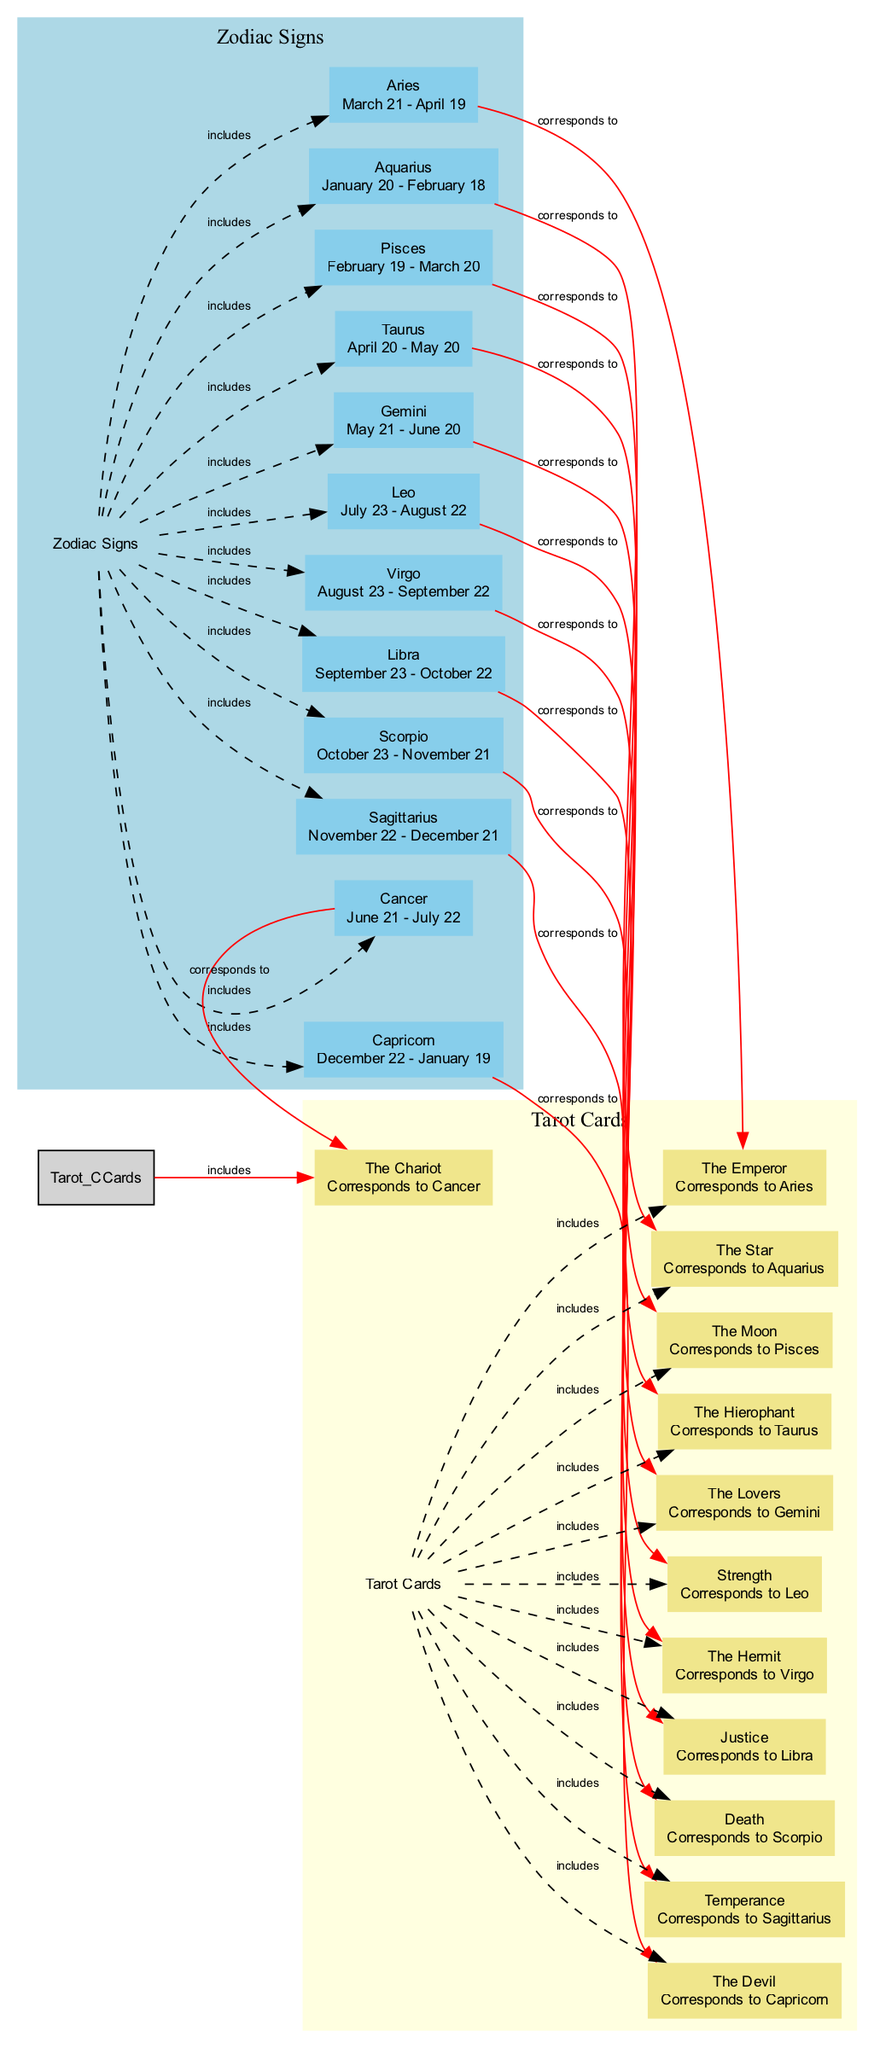What are the zodiac signs represented in the diagram? The diagram includes nodes for each of the twelve zodiac signs, which are Aries, Taurus, Gemini, Cancer, Leo, Virgo, Libra, Scorpio, Sagittarius, Capricorn, Aquarius, and Pisces.
Answer: Aries, Taurus, Gemini, Cancer, Leo, Virgo, Libra, Scorpio, Sagittarius, Capricorn, Aquarius, Pisces How many tarot cards are included in the diagram? The diagram shows twelve tarot cards, each corresponding to a zodiac sign. The cards are The Emperor, The Hierophant, The Lovers, The Chariot, Strength, The Hermit, Justice, Death, Temperance, The Devil, The Star, and The Moon.
Answer: Twelve Which zodiac sign corresponds to The Chariot? Looking at the edges that connect zodiac signs to tarot cards, Cancer is connected to The Chariot, indicating their correspondence.
Answer: Cancer Which tarot card corresponds to Sagittarius? The edge labeled "corresponds to" indicates that Sagittarius is linked with the tarot card Temperance, thus this card represents Sagittarius.
Answer: Temperance Which zodiac sign would you find in the diagram that corresponds to the tarot card Death? By identifying the edge labeled "corresponds to," it is evident that Scorpio is connected to the tarot card Death; hence, that is the corresponding zodiac sign.
Answer: Scorpio How many total edges are there in the diagram? Counting the edges listed in the data, there are 26 edges depicted in the diagram connecting different nodes (both zodiac signs and tarot cards).
Answer: Twenty-six What is the relationship between Aries and The Emperor in the diagram? The edge that reads "corresponds to" denotes that Aries directly corresponds to the tarot card The Emperor, illustrating their connection.
Answer: corresponds to Which zodiac sign corresponds to the tarot card Justice? The connection through the diagram shows that Libra is associated with the tarot card Justice, based on the edges indicating correspondence.
Answer: Libra 